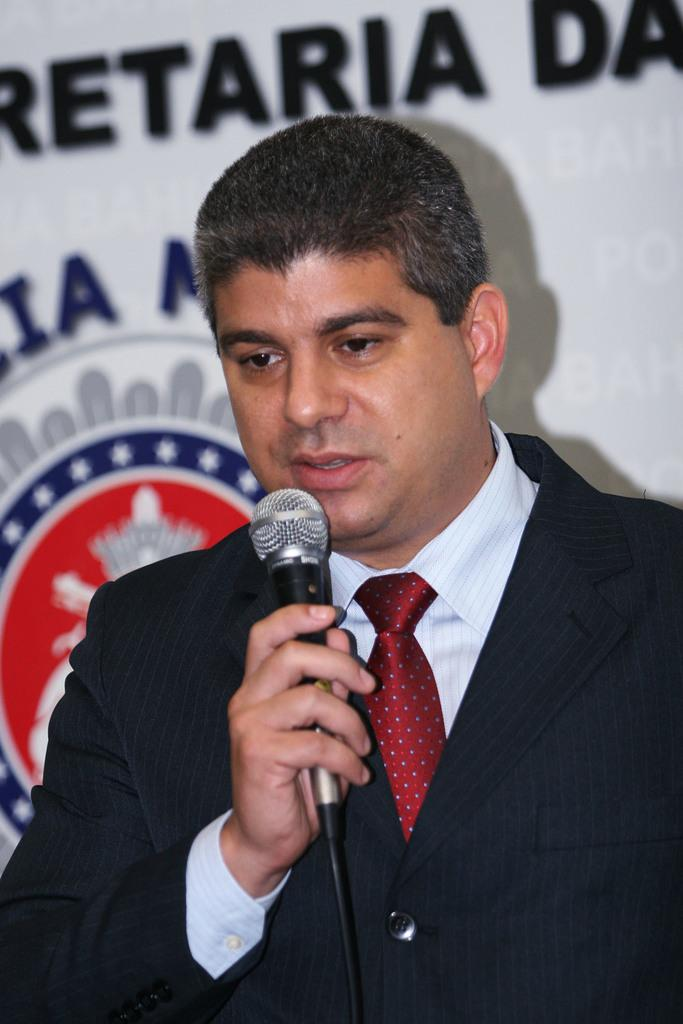What is the main subject of the image? The main subject of the image is a man. What type of clothing is the man wearing? The man is wearing a suit, a shirt, and a tie. What is the man holding in the image? The man is holding a microphone. How many dresses can be seen in the image? There are no dresses present in the image. What is the attraction that the man is attending in the image? The image does not provide information about an attraction or event that the man might be attending. 